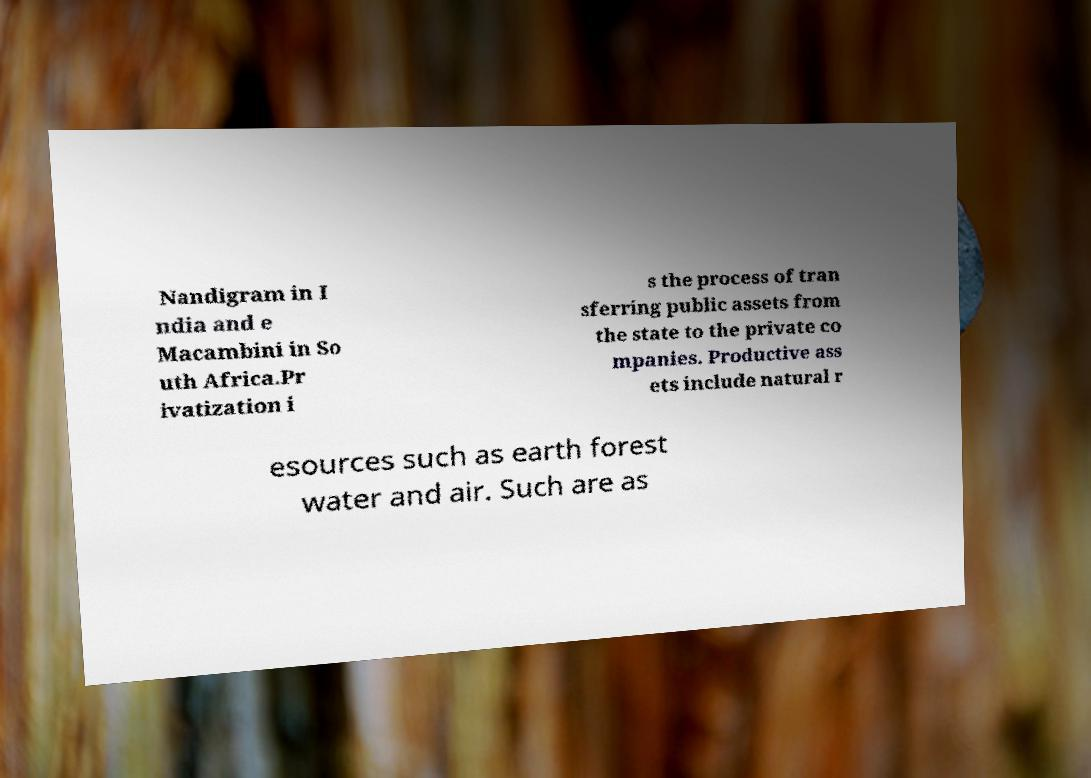Could you extract and type out the text from this image? Nandigram in I ndia and e Macambini in So uth Africa.Pr ivatization i s the process of tran sferring public assets from the state to the private co mpanies. Productive ass ets include natural r esources such as earth forest water and air. Such are as 